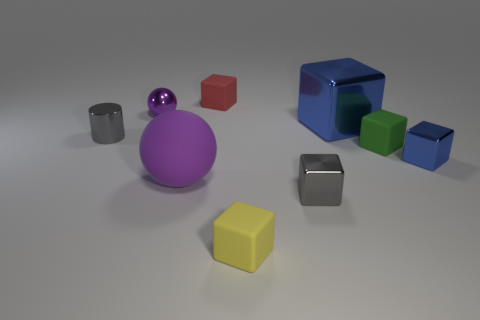How big is the gray metallic thing right of the tiny cube that is in front of the small gray metal thing to the right of the small purple metallic thing? The gray metallic object to the right of the tiny cube, which in turn is in front of another small gray item beside the small purple sphere, is relatively small, approximately twice the size of the tiny cube next to it. Its dimensions appear to be modest in comparison to larger objects in the image like the big blue cube and the yellow cube. 